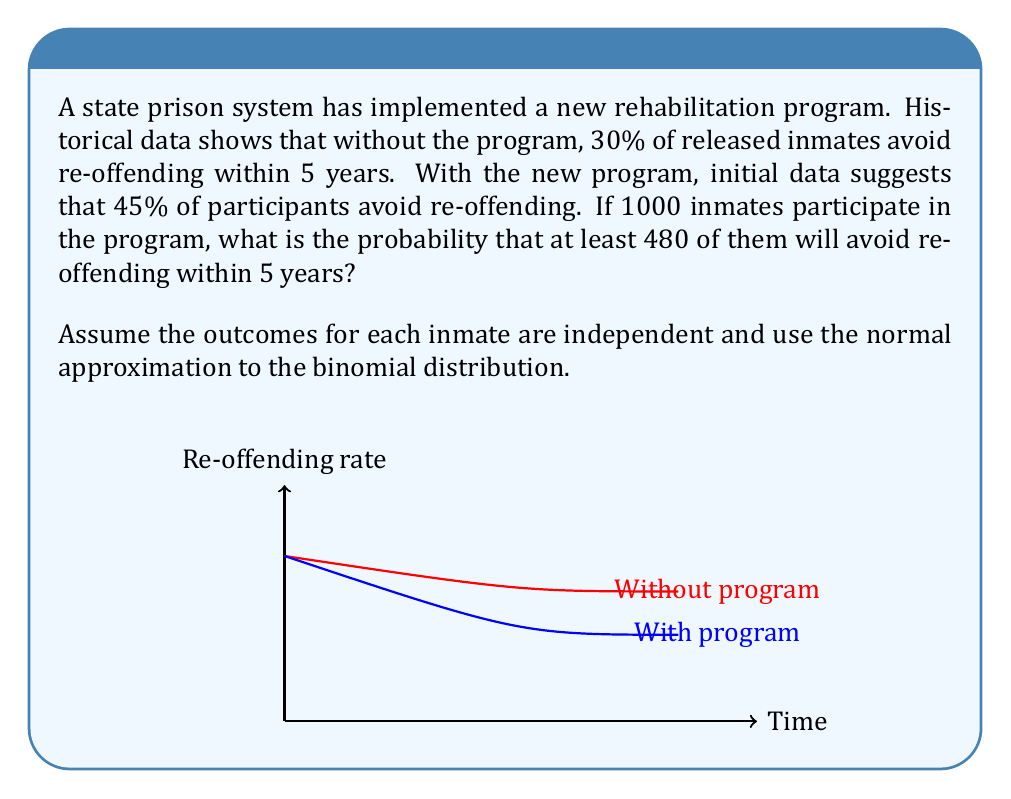Help me with this question. Let's approach this step-by-step:

1) This scenario follows a binomial distribution with:
   $n = 1000$ (number of inmates)
   $p = 0.45$ (probability of success for each inmate)

2) We want to find $P(X \geq 480)$ where $X$ is the number of successful rehabilitations.

3) For large $n$, we can approximate the binomial distribution with a normal distribution:
   $X \sim N(np, \sqrt{np(1-p)})$

4) Calculate the mean ($\mu$) and standard deviation ($\sigma$):
   $\mu = np = 1000 * 0.45 = 450$
   $\sigma = \sqrt{np(1-p)} = \sqrt{1000 * 0.45 * 0.55} = \sqrt{247.5} \approx 15.73$

5) Standardize the value we're interested in:
   $z = \frac{480 - 450}{15.73} \approx 1.91$

6) We want $P(X \geq 480)$, which is equivalent to $P(Z \geq 1.91)$

7) Using a standard normal table or calculator, we find:
   $P(Z \geq 1.91) = 1 - P(Z < 1.91) = 1 - 0.9719 = 0.0281$

Therefore, the probability that at least 480 out of 1000 inmates will avoid re-offending is approximately 0.0281 or 2.81%.
Answer: 0.0281 